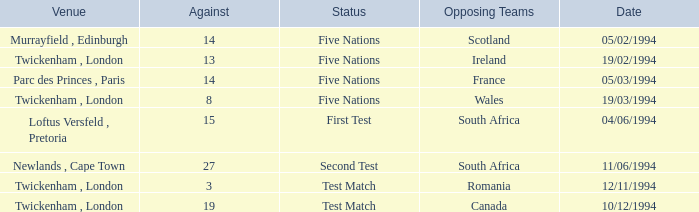Which venue has more than 19 against? Newlands , Cape Town. 